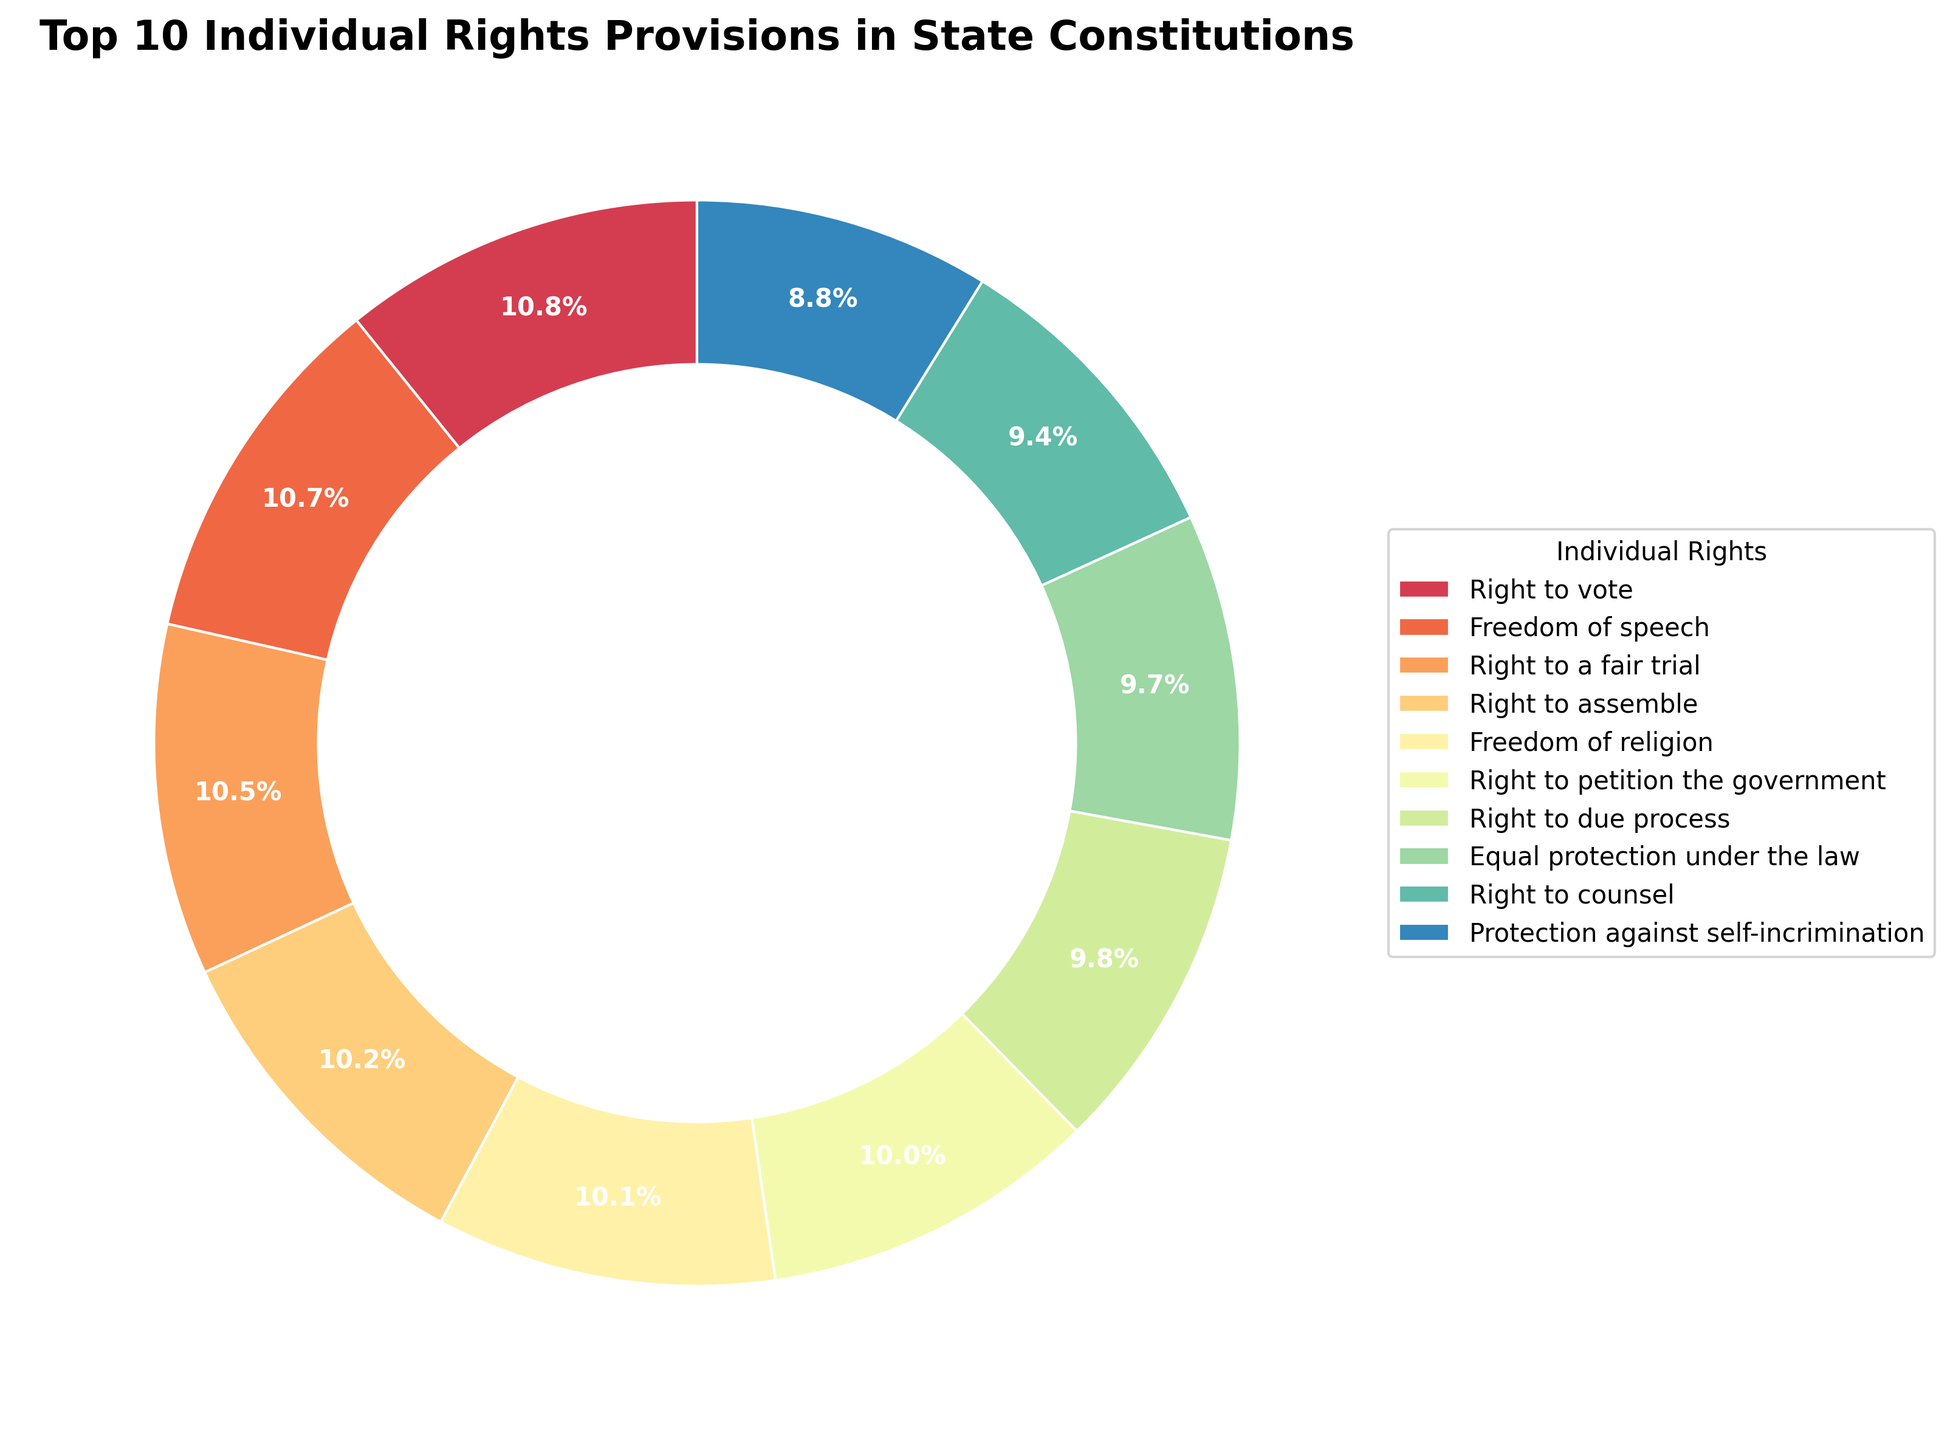What are the top three individual rights provisions in state constitutions according to the pie chart? The top three individual rights provisions in state constitutions can be determined by looking at the rights sections with the largest percentages in the chart legend. The top three are Right to Vote, Freedom of Speech, and Right to a Fair Trial.
Answer: Right to Vote, Freedom of Speech, Right to a Fair Trial Which individual rights provision is represented by the smallest slice? The smallest slice in the pie chart represents the right with the smallest percentage. By examining the chart, we see that the smallest slice corresponds to the Right to Healthcare.
Answer: Right to Healthcare How many individual rights provisions are shown in the pie chart? To determine the total number of individual rights provisions shown, count the number of different sections in the legend of the pie chart. There are ten sections in the legend.
Answer: 10 How does the proportion of states with the Right to Property compare with the proportion of states with the Right to Work? By comparing the slices or referencing the percentages, the Right to Property slice is larger than the Right to Work slice. The Right to Property has a higher proportion (65%) than the Right to Work (40%).
Answer: Right to Property is larger What is the combined proportion of states that have provisions for the Freedom of Speech and Freedom of Religion? Adding the percentages of states that have provisions for Freedom of Speech (97%) and Freedom of Religion (92%) gives the combined proportion. The combined proportion is 97 + 92 = 189%.
Answer: 189% Which individual rights provision is shown in a blue colored slice? The pie chart's legend can be used to match the color of the slices with their respective rights provisions. The Right to Due Process is represented by a blue-colored slice.
Answer: Right to Due Process Are there more states with provisions for the Protection against Cruel and Unusual Punishment or the Right to Counsel? Comparing the slices, the Right to Counsel has a larger slice than Protection against Cruel and Unusual Punishment. The proportion for Right to Counsel is higher (85%) compared to Protection against Cruel and Unusual Punishment (75%).
Answer: Right to Counsel What is the difference in proportion between the states with the Right to Education and those with Environmental Rights? Subtracting the percentage of states with Environmental Rights (33%) from the percentage with the Right to Education (60%) gives the difference. 60 - 33 = 27%.
Answer: 27% Which individual rights provision occupies the largest portion of the pie chart? The largest slice in the pie chart corresponds to the Right to Vote.
Answer: Right to Vote How does the proportion of states with the Right to Assemble compare to the Right to Petition the Government? Both rights provisions have similarly large slices, but checking the exact values shows that the Right to Assemble is slightly higher (93%) compared to the Right to Petition the Government (91%).
Answer: Right to Assemble is higher 